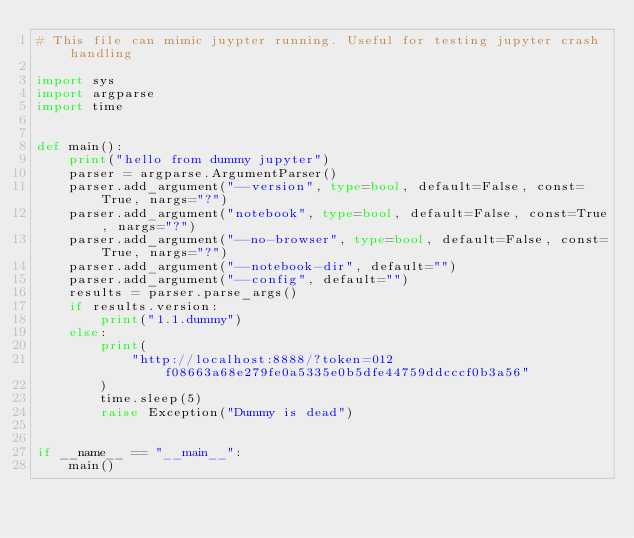Convert code to text. <code><loc_0><loc_0><loc_500><loc_500><_Python_># This file can mimic juypter running. Useful for testing jupyter crash handling

import sys
import argparse
import time


def main():
    print("hello from dummy jupyter")
    parser = argparse.ArgumentParser()
    parser.add_argument("--version", type=bool, default=False, const=True, nargs="?")
    parser.add_argument("notebook", type=bool, default=False, const=True, nargs="?")
    parser.add_argument("--no-browser", type=bool, default=False, const=True, nargs="?")
    parser.add_argument("--notebook-dir", default="")
    parser.add_argument("--config", default="")
    results = parser.parse_args()
    if results.version:
        print("1.1.dummy")
    else:
        print(
            "http://localhost:8888/?token=012f08663a68e279fe0a5335e0b5dfe44759ddcccf0b3a56"
        )
        time.sleep(5)
        raise Exception("Dummy is dead")


if __name__ == "__main__":
    main()
</code> 